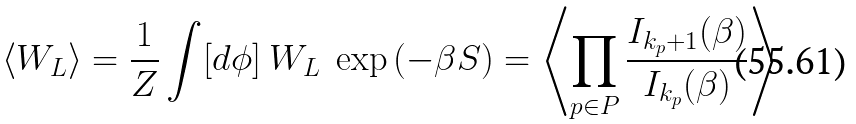Convert formula to latex. <formula><loc_0><loc_0><loc_500><loc_500>\langle W _ { L } \rangle = \frac { 1 } { Z } \int [ d \phi ] \ W _ { L } \ \exp \left ( - \beta S \right ) = \left \langle \prod _ { p \in P } \frac { I _ { k _ { p } + 1 } ( \beta ) } { I _ { k _ { p } } ( \beta ) } \right \rangle</formula> 